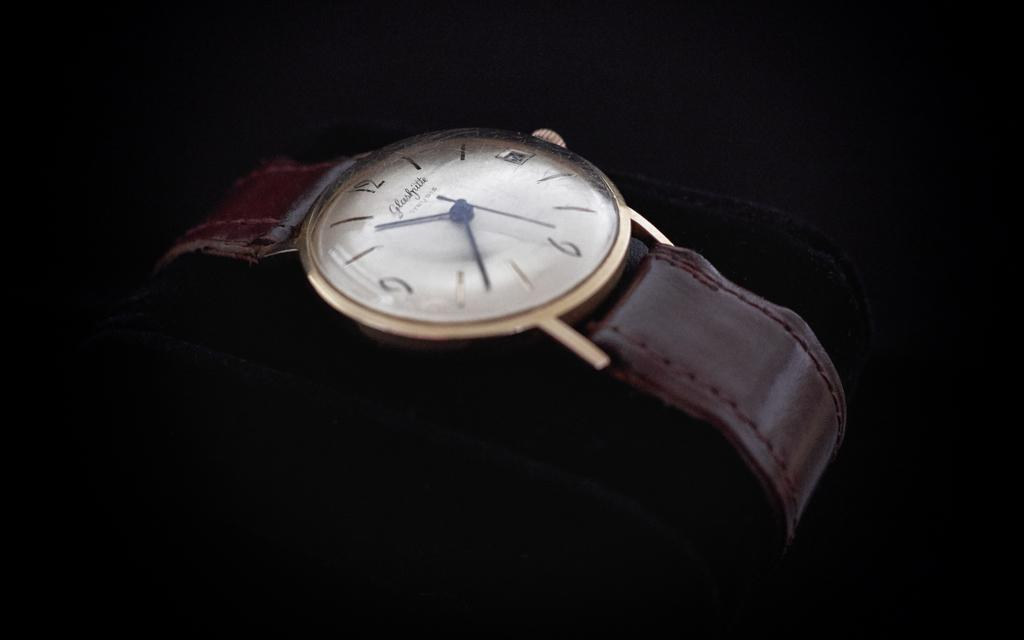<image>
Describe the image concisely. A watch with ten thirty eight as the time currently 